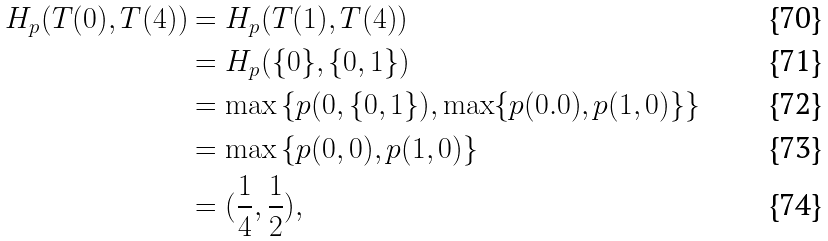Convert formula to latex. <formula><loc_0><loc_0><loc_500><loc_500>H _ { p } ( T ( 0 ) , T ( 4 ) ) & = H _ { p } ( T ( 1 ) , T ( 4 ) ) \\ & = H _ { p } ( \{ 0 \} , \{ 0 , 1 \} ) \\ & = \max \left \{ p ( 0 , \{ 0 , 1 \} ) , \max \{ p ( 0 . 0 ) , p ( 1 , 0 ) \} \right \} \\ & = \max \left \{ p ( 0 , 0 ) , p ( 1 , 0 ) \right \} \\ & = ( \frac { 1 } { 4 } , \frac { 1 } { 2 } ) ,</formula> 